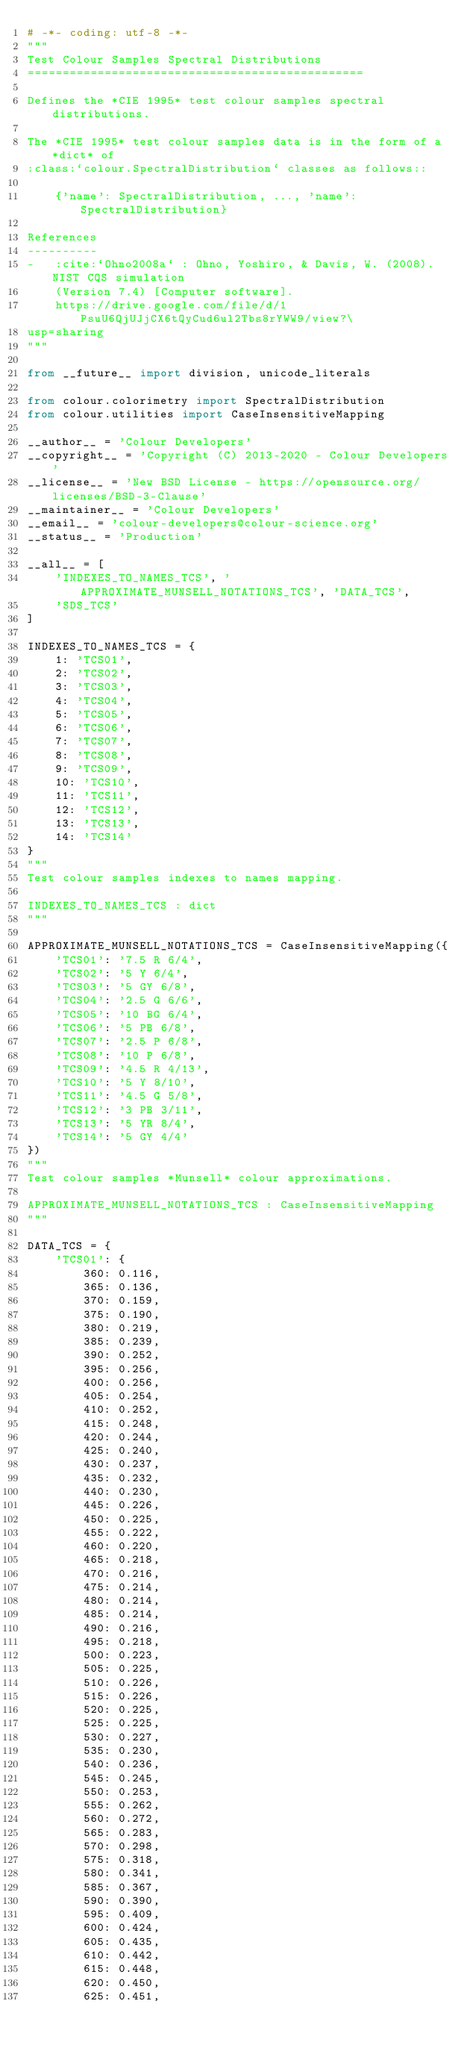<code> <loc_0><loc_0><loc_500><loc_500><_Python_># -*- coding: utf-8 -*-
"""
Test Colour Samples Spectral Distributions
================================================

Defines the *CIE 1995* test colour samples spectral distributions.

The *CIE 1995* test colour samples data is in the form of a *dict* of
:class:`colour.SpectralDistribution` classes as follows::

    {'name': SpectralDistribution, ..., 'name': SpectralDistribution}

References
----------
-   :cite:`Ohno2008a` : Ohno, Yoshiro, & Davis, W. (2008). NIST CQS simulation
    (Version 7.4) [Computer software].
    https://drive.google.com/file/d/1PsuU6QjUJjCX6tQyCud6ul2Tbs8rYWW9/view?\
usp=sharing
"""

from __future__ import division, unicode_literals

from colour.colorimetry import SpectralDistribution
from colour.utilities import CaseInsensitiveMapping

__author__ = 'Colour Developers'
__copyright__ = 'Copyright (C) 2013-2020 - Colour Developers'
__license__ = 'New BSD License - https://opensource.org/licenses/BSD-3-Clause'
__maintainer__ = 'Colour Developers'
__email__ = 'colour-developers@colour-science.org'
__status__ = 'Production'

__all__ = [
    'INDEXES_TO_NAMES_TCS', 'APPROXIMATE_MUNSELL_NOTATIONS_TCS', 'DATA_TCS',
    'SDS_TCS'
]

INDEXES_TO_NAMES_TCS = {
    1: 'TCS01',
    2: 'TCS02',
    3: 'TCS03',
    4: 'TCS04',
    5: 'TCS05',
    6: 'TCS06',
    7: 'TCS07',
    8: 'TCS08',
    9: 'TCS09',
    10: 'TCS10',
    11: 'TCS11',
    12: 'TCS12',
    13: 'TCS13',
    14: 'TCS14'
}
"""
Test colour samples indexes to names mapping.

INDEXES_TO_NAMES_TCS : dict
"""

APPROXIMATE_MUNSELL_NOTATIONS_TCS = CaseInsensitiveMapping({
    'TCS01': '7.5 R 6/4',
    'TCS02': '5 Y 6/4',
    'TCS03': '5 GY 6/8',
    'TCS04': '2.5 G 6/6',
    'TCS05': '10 BG 6/4',
    'TCS06': '5 PB 6/8',
    'TCS07': '2.5 P 6/8',
    'TCS08': '10 P 6/8',
    'TCS09': '4.5 R 4/13',
    'TCS10': '5 Y 8/10',
    'TCS11': '4.5 G 5/8',
    'TCS12': '3 PB 3/11',
    'TCS13': '5 YR 8/4',
    'TCS14': '5 GY 4/4'
})
"""
Test colour samples *Munsell* colour approximations.

APPROXIMATE_MUNSELL_NOTATIONS_TCS : CaseInsensitiveMapping
"""

DATA_TCS = {
    'TCS01': {
        360: 0.116,
        365: 0.136,
        370: 0.159,
        375: 0.190,
        380: 0.219,
        385: 0.239,
        390: 0.252,
        395: 0.256,
        400: 0.256,
        405: 0.254,
        410: 0.252,
        415: 0.248,
        420: 0.244,
        425: 0.240,
        430: 0.237,
        435: 0.232,
        440: 0.230,
        445: 0.226,
        450: 0.225,
        455: 0.222,
        460: 0.220,
        465: 0.218,
        470: 0.216,
        475: 0.214,
        480: 0.214,
        485: 0.214,
        490: 0.216,
        495: 0.218,
        500: 0.223,
        505: 0.225,
        510: 0.226,
        515: 0.226,
        520: 0.225,
        525: 0.225,
        530: 0.227,
        535: 0.230,
        540: 0.236,
        545: 0.245,
        550: 0.253,
        555: 0.262,
        560: 0.272,
        565: 0.283,
        570: 0.298,
        575: 0.318,
        580: 0.341,
        585: 0.367,
        590: 0.390,
        595: 0.409,
        600: 0.424,
        605: 0.435,
        610: 0.442,
        615: 0.448,
        620: 0.450,
        625: 0.451,</code> 